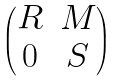<formula> <loc_0><loc_0><loc_500><loc_500>\begin{pmatrix} R & M \\ 0 & S \end{pmatrix}</formula> 